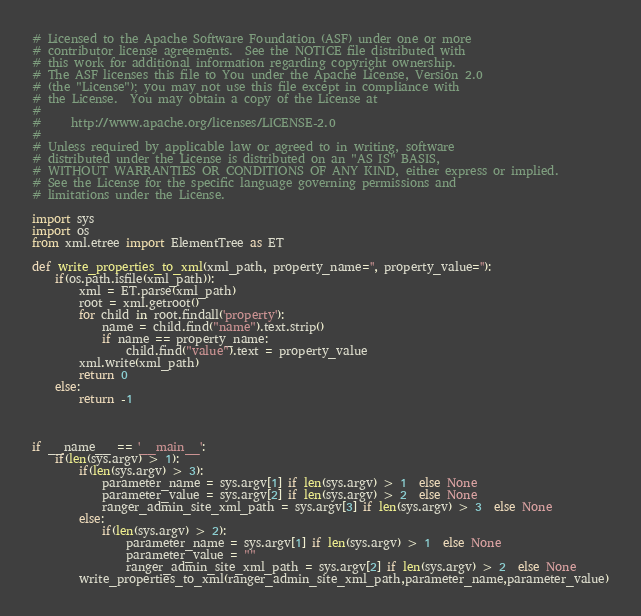Convert code to text. <code><loc_0><loc_0><loc_500><loc_500><_Python_># Licensed to the Apache Software Foundation (ASF) under one or more
# contributor license agreements.  See the NOTICE file distributed with
# this work for additional information regarding copyright ownership.
# The ASF licenses this file to You under the Apache License, Version 2.0
# (the "License"); you may not use this file except in compliance with
# the License.  You may obtain a copy of the License at
#
#     http://www.apache.org/licenses/LICENSE-2.0
#
# Unless required by applicable law or agreed to in writing, software
# distributed under the License is distributed on an "AS IS" BASIS,
# WITHOUT WARRANTIES OR CONDITIONS OF ANY KIND, either express or implied.
# See the License for the specific language governing permissions and
# limitations under the License.

import sys
import os
from xml.etree import ElementTree as ET

def write_properties_to_xml(xml_path, property_name='', property_value=''):
	if(os.path.isfile(xml_path)):
		xml = ET.parse(xml_path)
		root = xml.getroot()
		for child in root.findall('property'):
			name = child.find("name").text.strip()
			if name == property_name:
				child.find("value").text = property_value
		xml.write(xml_path)
		return 0
	else:
		return -1



if __name__ == '__main__':
	if(len(sys.argv) > 1):
		if(len(sys.argv) > 3):
			parameter_name = sys.argv[1] if len(sys.argv) > 1  else None
			parameter_value = sys.argv[2] if len(sys.argv) > 2  else None
			ranger_admin_site_xml_path = sys.argv[3] if len(sys.argv) > 3  else None
		else:
			if(len(sys.argv) > 2):
				parameter_name = sys.argv[1] if len(sys.argv) > 1  else None
				parameter_value = ""
				ranger_admin_site_xml_path = sys.argv[2] if len(sys.argv) > 2  else None
		write_properties_to_xml(ranger_admin_site_xml_path,parameter_name,parameter_value)
</code> 